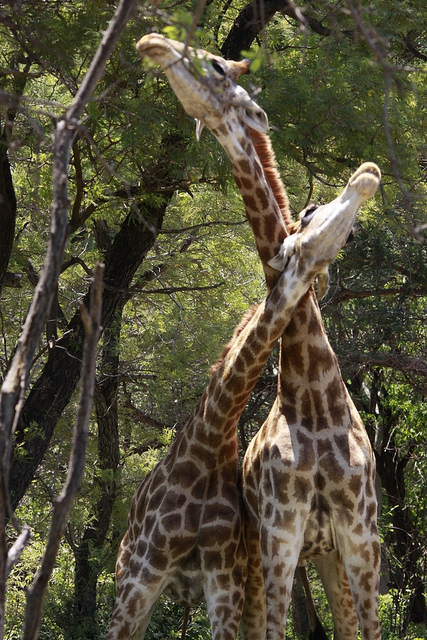What are the giraffes doing in this picture? The giraffes appear to be engaging in a behavior known as 'necking,' which is a form of social interaction. They might be practicing a mild form where they rub and lean their necks against one another. This can be a way to establish social bonds or dominance. 